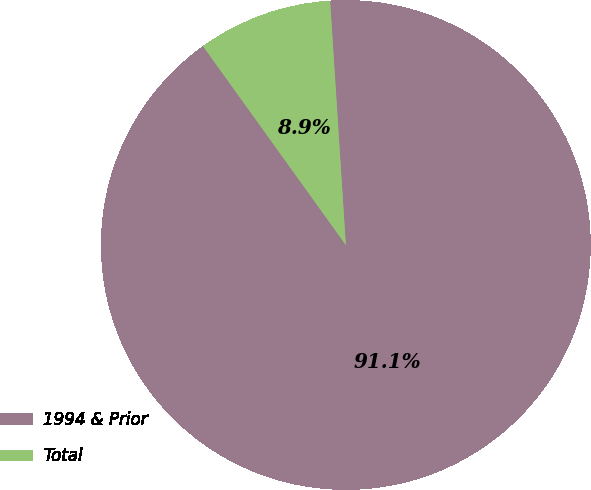Convert chart. <chart><loc_0><loc_0><loc_500><loc_500><pie_chart><fcel>1994 & Prior<fcel>Total<nl><fcel>91.11%<fcel>8.89%<nl></chart> 